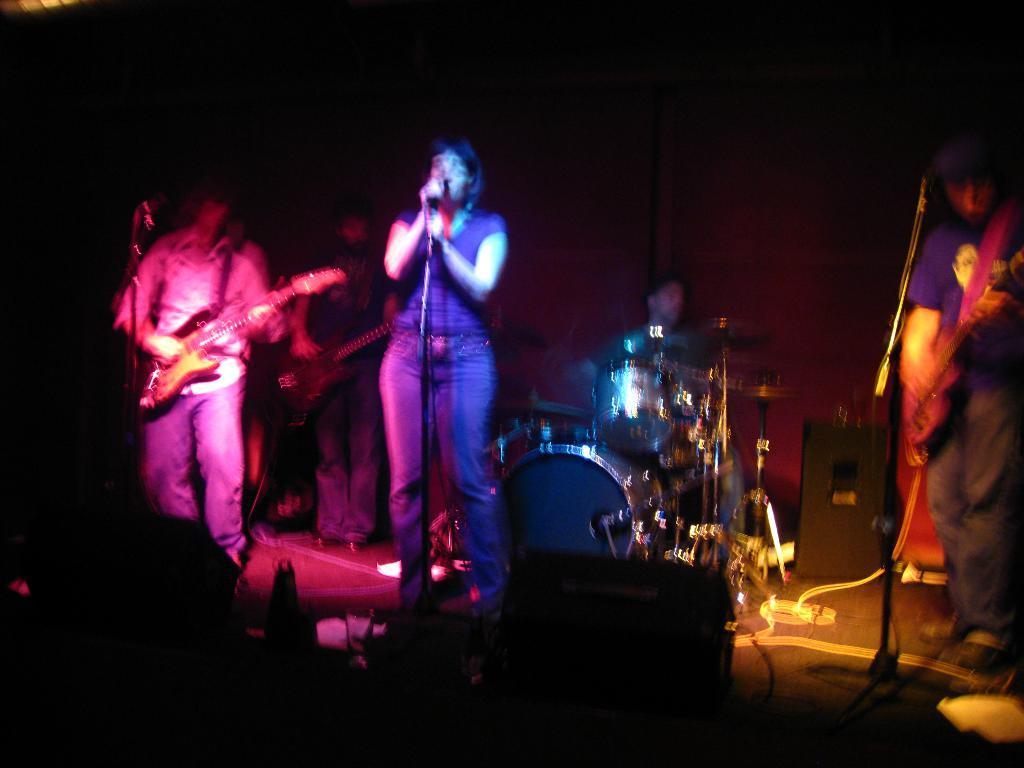How would you summarize this image in a sentence or two? This image is taken in a concert. In the middle of the image a woman standing holding a mic and singing. In the left side of the image there is a man standing holding a guitar in his hands. There are few musical instruments on the stage. 